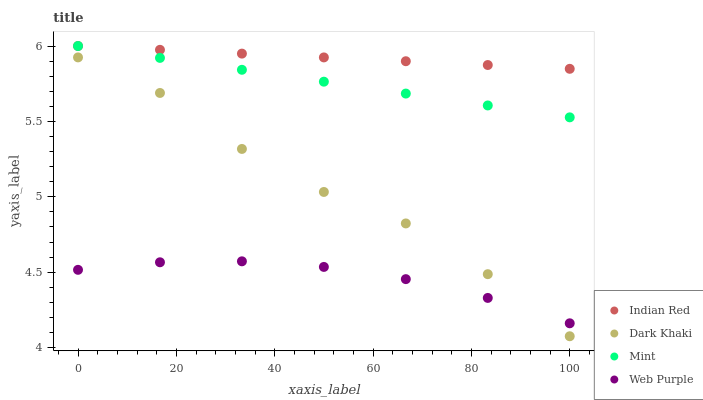Does Web Purple have the minimum area under the curve?
Answer yes or no. Yes. Does Indian Red have the maximum area under the curve?
Answer yes or no. Yes. Does Mint have the minimum area under the curve?
Answer yes or no. No. Does Mint have the maximum area under the curve?
Answer yes or no. No. Is Indian Red the smoothest?
Answer yes or no. Yes. Is Dark Khaki the roughest?
Answer yes or no. Yes. Is Web Purple the smoothest?
Answer yes or no. No. Is Web Purple the roughest?
Answer yes or no. No. Does Dark Khaki have the lowest value?
Answer yes or no. Yes. Does Web Purple have the lowest value?
Answer yes or no. No. Does Indian Red have the highest value?
Answer yes or no. Yes. Does Web Purple have the highest value?
Answer yes or no. No. Is Dark Khaki less than Indian Red?
Answer yes or no. Yes. Is Mint greater than Web Purple?
Answer yes or no. Yes. Does Mint intersect Indian Red?
Answer yes or no. Yes. Is Mint less than Indian Red?
Answer yes or no. No. Is Mint greater than Indian Red?
Answer yes or no. No. Does Dark Khaki intersect Indian Red?
Answer yes or no. No. 